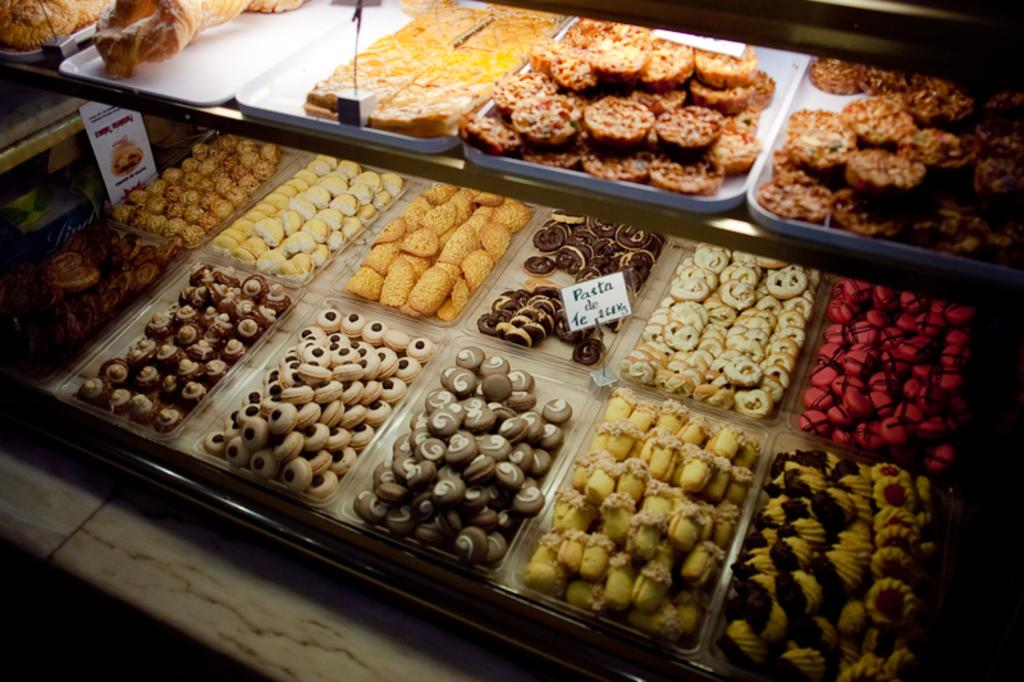What is present on the plate in the image? There are food items in the plate. What can be seen besides the plate in the image? There is a board with text written on it. How does the board provide support to the food items in the image? The board does not provide support to the food items in the image; it is a separate element with text written on it. 